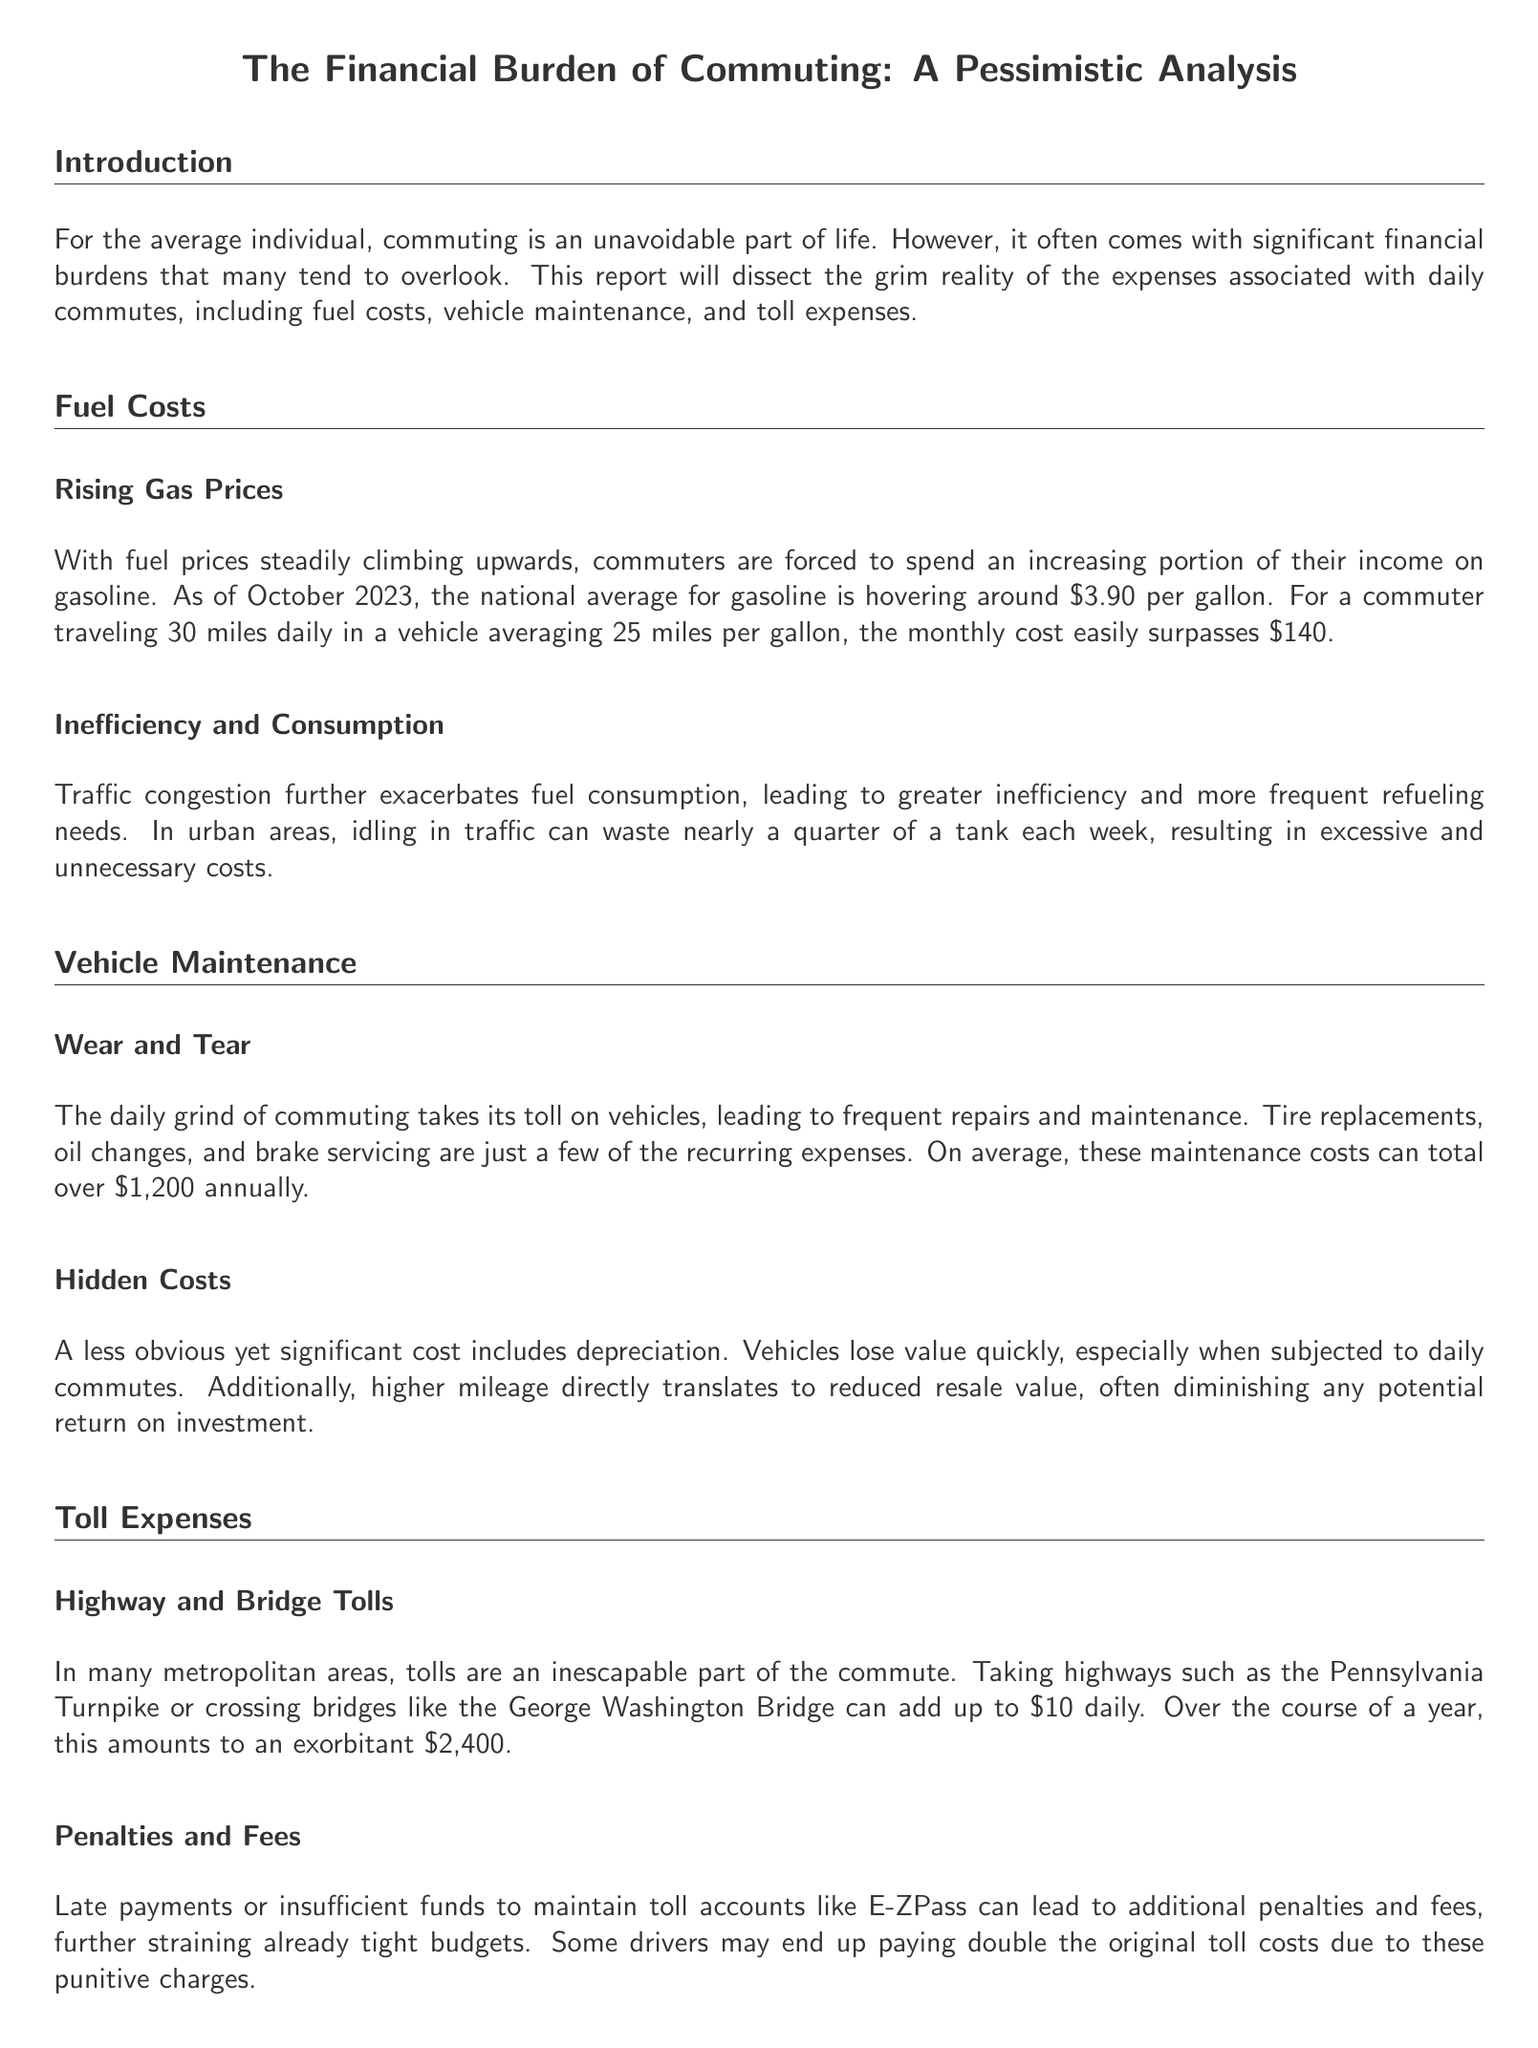what is the national average for gasoline as of October 2023? The document states that the national average for gasoline is hovering around $3.90 per gallon.
Answer: $3.90 what is the estimated monthly cost for fuel if commuting 30 miles daily? The document indicates that for a commuter traveling 30 miles daily, the monthly cost easily surpasses $140.
Answer: over $140 how much can average annual vehicle maintenance costs total? The report mentions that average maintenance costs can total over $1,200 annually.
Answer: over $1,200 what is the annual toll expense for high-use commuters? The document calculates that tolls can add up to an exorbitant $2,400 over the course of a year.
Answer: $2,400 what percentage of a tank can be wasted idling in traffic? The document states that idling in traffic can waste nearly a quarter of a tank each week.
Answer: a quarter how does commuting affect vehicle depreciation? The report notes that vehicles lose value quickly, especially when subjected to daily commutes.
Answer: quickly what is a potential penalty for late toll payments? The document mentions that late payments can lead to additional penalties and fees.
Answer: additional penalties and fees what is a common consequence of higher mileage on resale value? The report indicates that higher mileage directly translates to reduced resale value.
Answer: reduced resale value how much can punitive charges increase toll costs? The document suggests that some drivers may end up paying double the original toll costs due to punitive charges.
Answer: double 